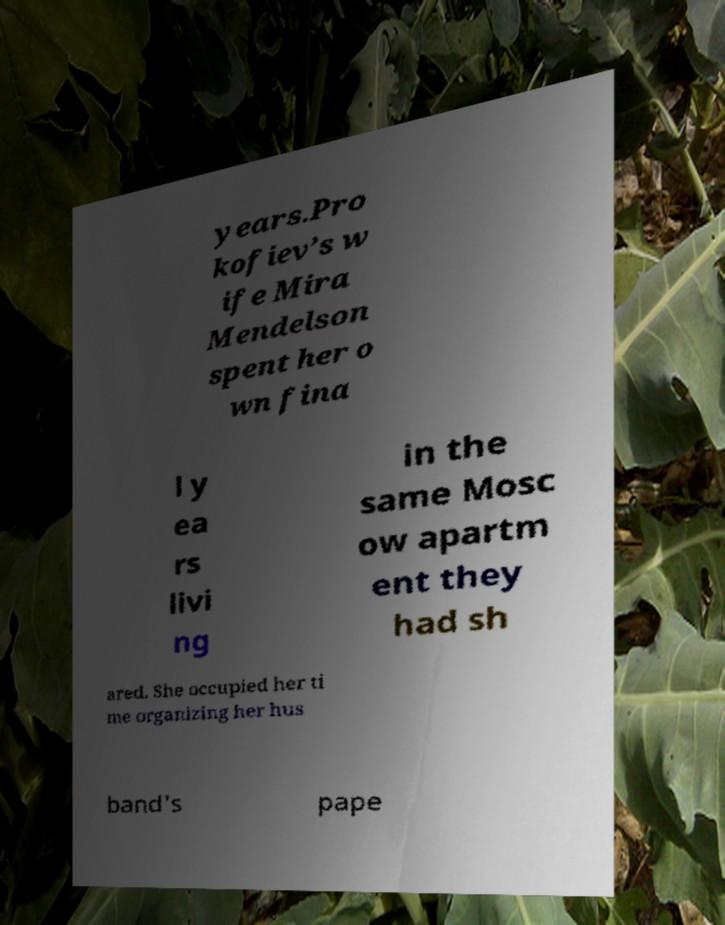Could you assist in decoding the text presented in this image and type it out clearly? years.Pro kofiev’s w ife Mira Mendelson spent her o wn fina l y ea rs livi ng in the same Mosc ow apartm ent they had sh ared. She occupied her ti me organizing her hus band's pape 